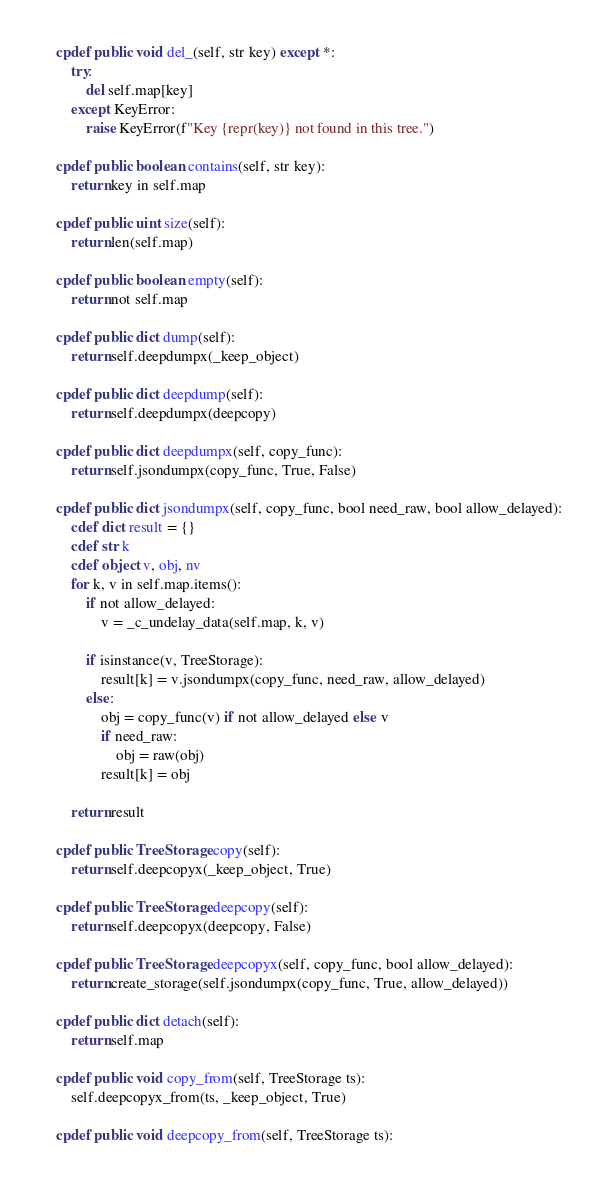Convert code to text. <code><loc_0><loc_0><loc_500><loc_500><_Cython_>    cpdef public void del_(self, str key) except *:
        try:
            del self.map[key]
        except KeyError:
            raise KeyError(f"Key {repr(key)} not found in this tree.")

    cpdef public boolean contains(self, str key):
        return key in self.map

    cpdef public uint size(self):
        return len(self.map)

    cpdef public boolean empty(self):
        return not self.map

    cpdef public dict dump(self):
        return self.deepdumpx(_keep_object)

    cpdef public dict deepdump(self):
        return self.deepdumpx(deepcopy)

    cpdef public dict deepdumpx(self, copy_func):
        return self.jsondumpx(copy_func, True, False)

    cpdef public dict jsondumpx(self, copy_func, bool need_raw, bool allow_delayed):
        cdef dict result = {}
        cdef str k
        cdef object v, obj, nv
        for k, v in self.map.items():
            if not allow_delayed:
                v = _c_undelay_data(self.map, k, v)

            if isinstance(v, TreeStorage):
                result[k] = v.jsondumpx(copy_func, need_raw, allow_delayed)
            else:
                obj = copy_func(v) if not allow_delayed else v
                if need_raw:
                    obj = raw(obj)
                result[k] = obj

        return result

    cpdef public TreeStorage copy(self):
        return self.deepcopyx(_keep_object, True)

    cpdef public TreeStorage deepcopy(self):
        return self.deepcopyx(deepcopy, False)

    cpdef public TreeStorage deepcopyx(self, copy_func, bool allow_delayed):
        return create_storage(self.jsondumpx(copy_func, True, allow_delayed))

    cpdef public dict detach(self):
        return self.map

    cpdef public void copy_from(self, TreeStorage ts):
        self.deepcopyx_from(ts, _keep_object, True)

    cpdef public void deepcopy_from(self, TreeStorage ts):</code> 